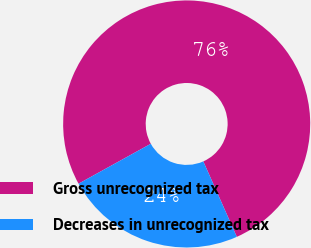Convert chart. <chart><loc_0><loc_0><loc_500><loc_500><pie_chart><fcel>Gross unrecognized tax<fcel>Decreases in unrecognized tax<nl><fcel>76.38%<fcel>23.62%<nl></chart> 